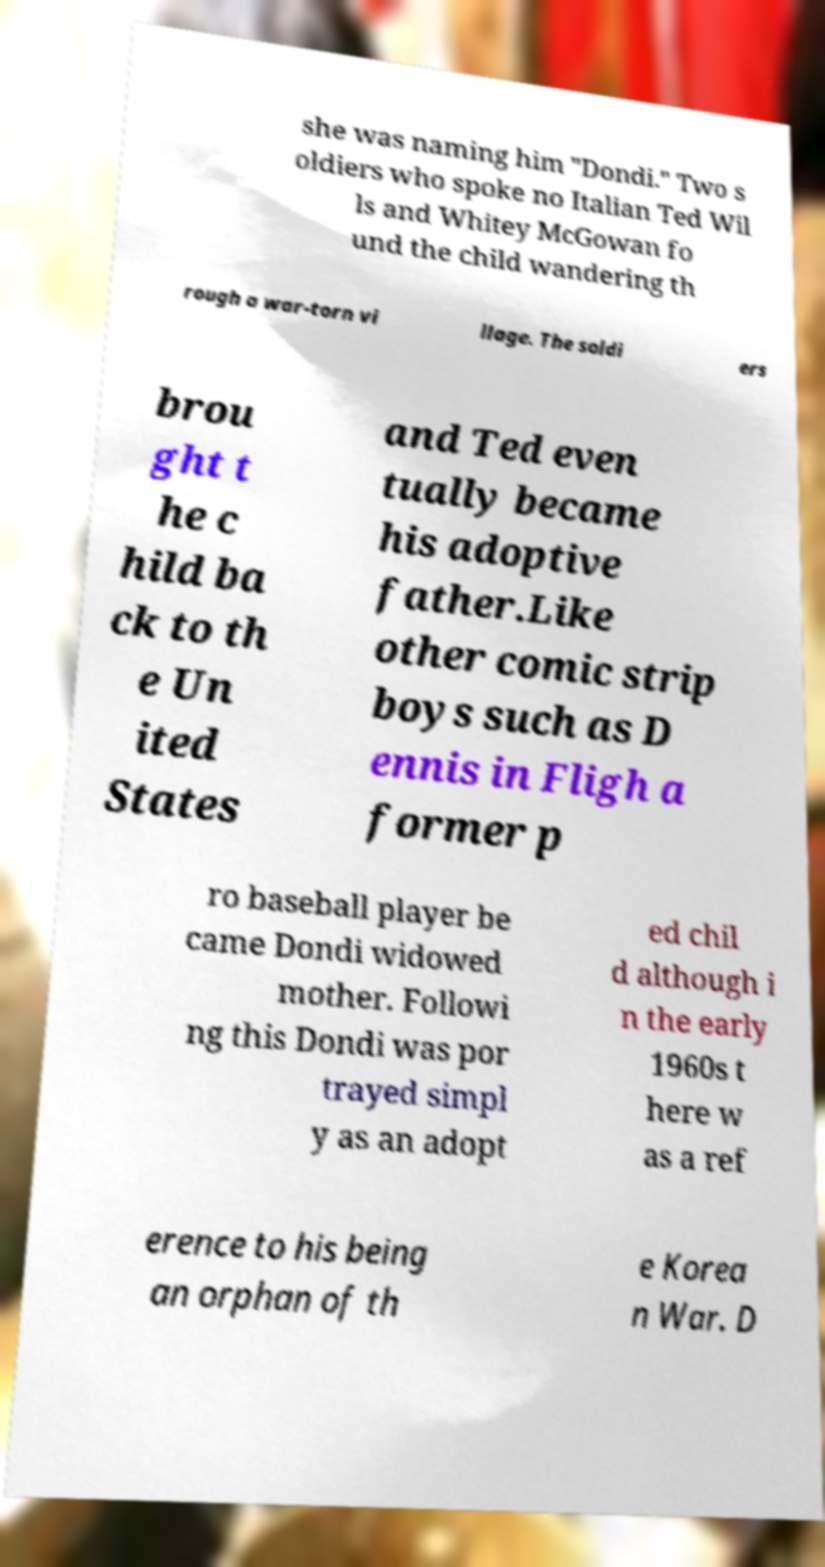Can you read and provide the text displayed in the image?This photo seems to have some interesting text. Can you extract and type it out for me? she was naming him "Dondi." Two s oldiers who spoke no Italian Ted Wil ls and Whitey McGowan fo und the child wandering th rough a war-torn vi llage. The soldi ers brou ght t he c hild ba ck to th e Un ited States and Ted even tually became his adoptive father.Like other comic strip boys such as D ennis in Fligh a former p ro baseball player be came Dondi widowed mother. Followi ng this Dondi was por trayed simpl y as an adopt ed chil d although i n the early 1960s t here w as a ref erence to his being an orphan of th e Korea n War. D 